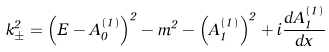Convert formula to latex. <formula><loc_0><loc_0><loc_500><loc_500>k _ { \pm } ^ { 2 } = \left ( E - A _ { 0 } ^ { \left ( 1 \right ) } \right ) ^ { 2 } - m ^ { 2 } - \left ( A _ { 1 } ^ { \left ( 1 \right ) } \right ) ^ { 2 } + i \frac { d A _ { 1 } ^ { \left ( 1 \right ) } } { d x }</formula> 